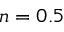Convert formula to latex. <formula><loc_0><loc_0><loc_500><loc_500>n = 0 . 5</formula> 